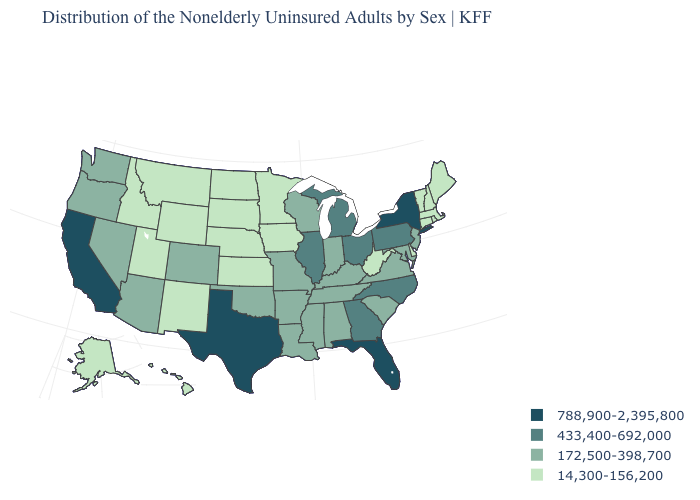Name the states that have a value in the range 172,500-398,700?
Give a very brief answer. Alabama, Arizona, Arkansas, Colorado, Indiana, Kentucky, Louisiana, Maryland, Mississippi, Missouri, Nevada, New Jersey, Oklahoma, Oregon, South Carolina, Tennessee, Virginia, Washington, Wisconsin. How many symbols are there in the legend?
Concise answer only. 4. Name the states that have a value in the range 14,300-156,200?
Quick response, please. Alaska, Connecticut, Delaware, Hawaii, Idaho, Iowa, Kansas, Maine, Massachusetts, Minnesota, Montana, Nebraska, New Hampshire, New Mexico, North Dakota, Rhode Island, South Dakota, Utah, Vermont, West Virginia, Wyoming. Name the states that have a value in the range 14,300-156,200?
Answer briefly. Alaska, Connecticut, Delaware, Hawaii, Idaho, Iowa, Kansas, Maine, Massachusetts, Minnesota, Montana, Nebraska, New Hampshire, New Mexico, North Dakota, Rhode Island, South Dakota, Utah, Vermont, West Virginia, Wyoming. Name the states that have a value in the range 788,900-2,395,800?
Concise answer only. California, Florida, New York, Texas. Does the map have missing data?
Short answer required. No. Does South Dakota have the lowest value in the MidWest?
Answer briefly. Yes. Does South Dakota have the highest value in the MidWest?
Quick response, please. No. Does the first symbol in the legend represent the smallest category?
Write a very short answer. No. Which states have the highest value in the USA?
Keep it brief. California, Florida, New York, Texas. Name the states that have a value in the range 172,500-398,700?
Write a very short answer. Alabama, Arizona, Arkansas, Colorado, Indiana, Kentucky, Louisiana, Maryland, Mississippi, Missouri, Nevada, New Jersey, Oklahoma, Oregon, South Carolina, Tennessee, Virginia, Washington, Wisconsin. Among the states that border Louisiana , which have the lowest value?
Quick response, please. Arkansas, Mississippi. Does Oklahoma have a lower value than Alaska?
Give a very brief answer. No. Does Vermont have the lowest value in the Northeast?
Answer briefly. Yes. Which states have the lowest value in the West?
Write a very short answer. Alaska, Hawaii, Idaho, Montana, New Mexico, Utah, Wyoming. 